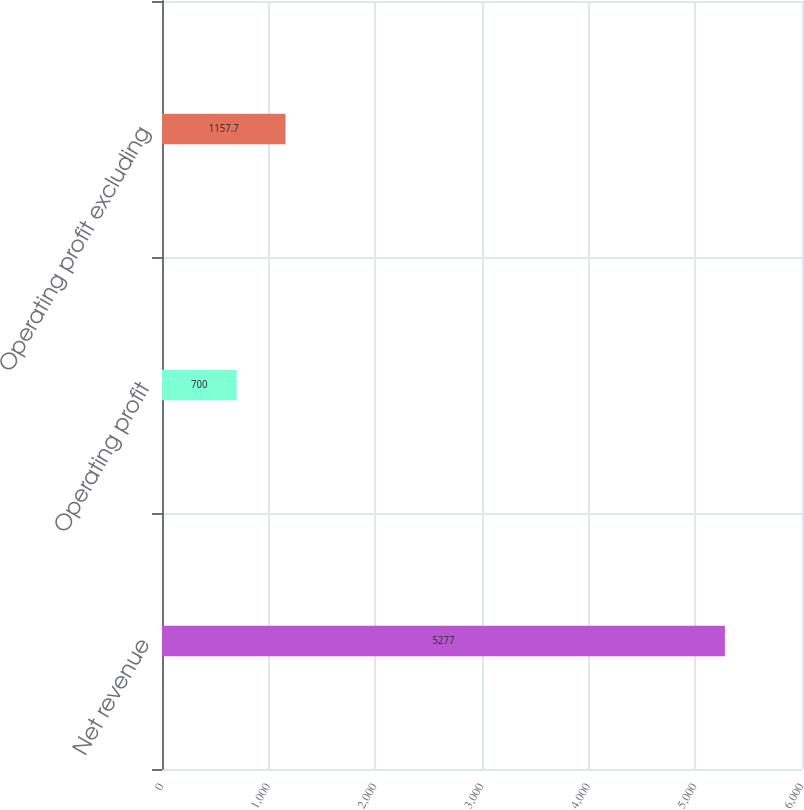<chart> <loc_0><loc_0><loc_500><loc_500><bar_chart><fcel>Net revenue<fcel>Operating profit<fcel>Operating profit excluding<nl><fcel>5277<fcel>700<fcel>1157.7<nl></chart> 